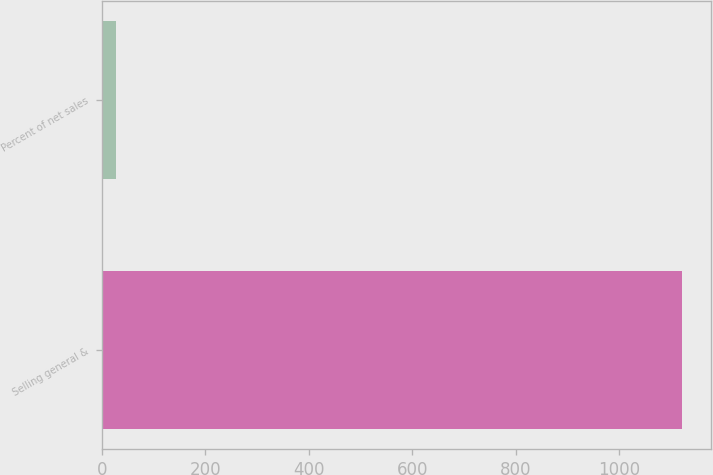Convert chart to OTSL. <chart><loc_0><loc_0><loc_500><loc_500><bar_chart><fcel>Selling general &<fcel>Percent of net sales<nl><fcel>1122<fcel>26.5<nl></chart> 